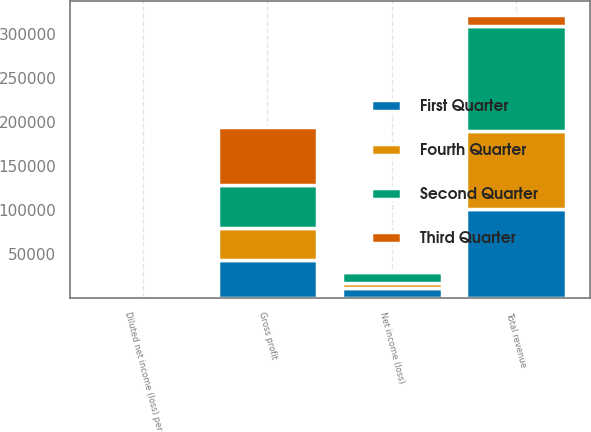Convert chart to OTSL. <chart><loc_0><loc_0><loc_500><loc_500><stacked_bar_chart><ecel><fcel>Total revenue<fcel>Gross profit<fcel>Net income (loss)<fcel>Diluted net income (loss) per<nl><fcel>Fourth Quarter<fcel>87956<fcel>36290<fcel>5716<fcel>0.12<nl><fcel>First Quarter<fcel>100985<fcel>42429<fcel>11164<fcel>0.24<nl><fcel>Second Quarter<fcel>119685<fcel>49660<fcel>12017<fcel>0.25<nl><fcel>Third Quarter<fcel>12017<fcel>65153<fcel>1473<fcel>0.03<nl></chart> 